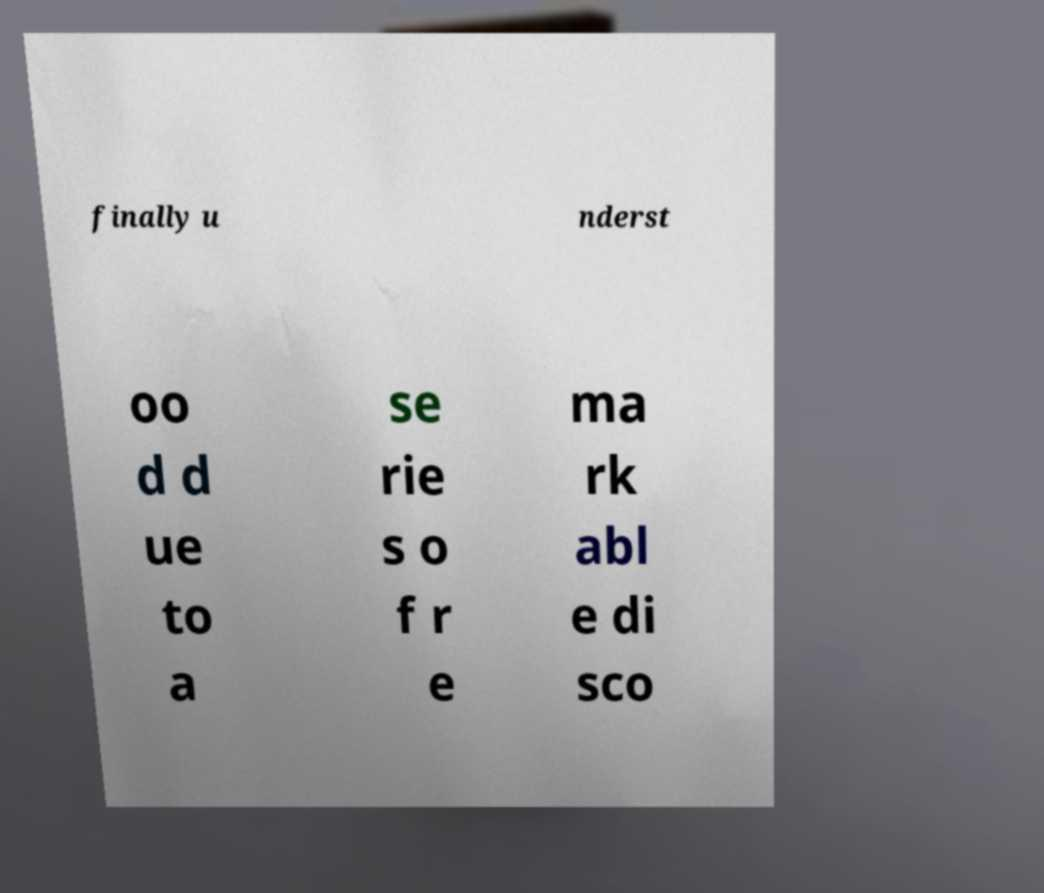For documentation purposes, I need the text within this image transcribed. Could you provide that? finally u nderst oo d d ue to a se rie s o f r e ma rk abl e di sco 